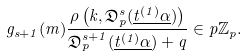Convert formula to latex. <formula><loc_0><loc_0><loc_500><loc_500>g _ { s + 1 } ( m ) \frac { \rho \left ( k , \mathfrak { D } _ { p } ^ { s } ( \underline { t ^ { ( 1 ) } \alpha } ) \right ) } { \mathfrak { D } _ { p } ^ { s + 1 } ( \underline { t ^ { ( 1 ) } \alpha } ) + q } \in p \mathbb { Z } _ { p } .</formula> 